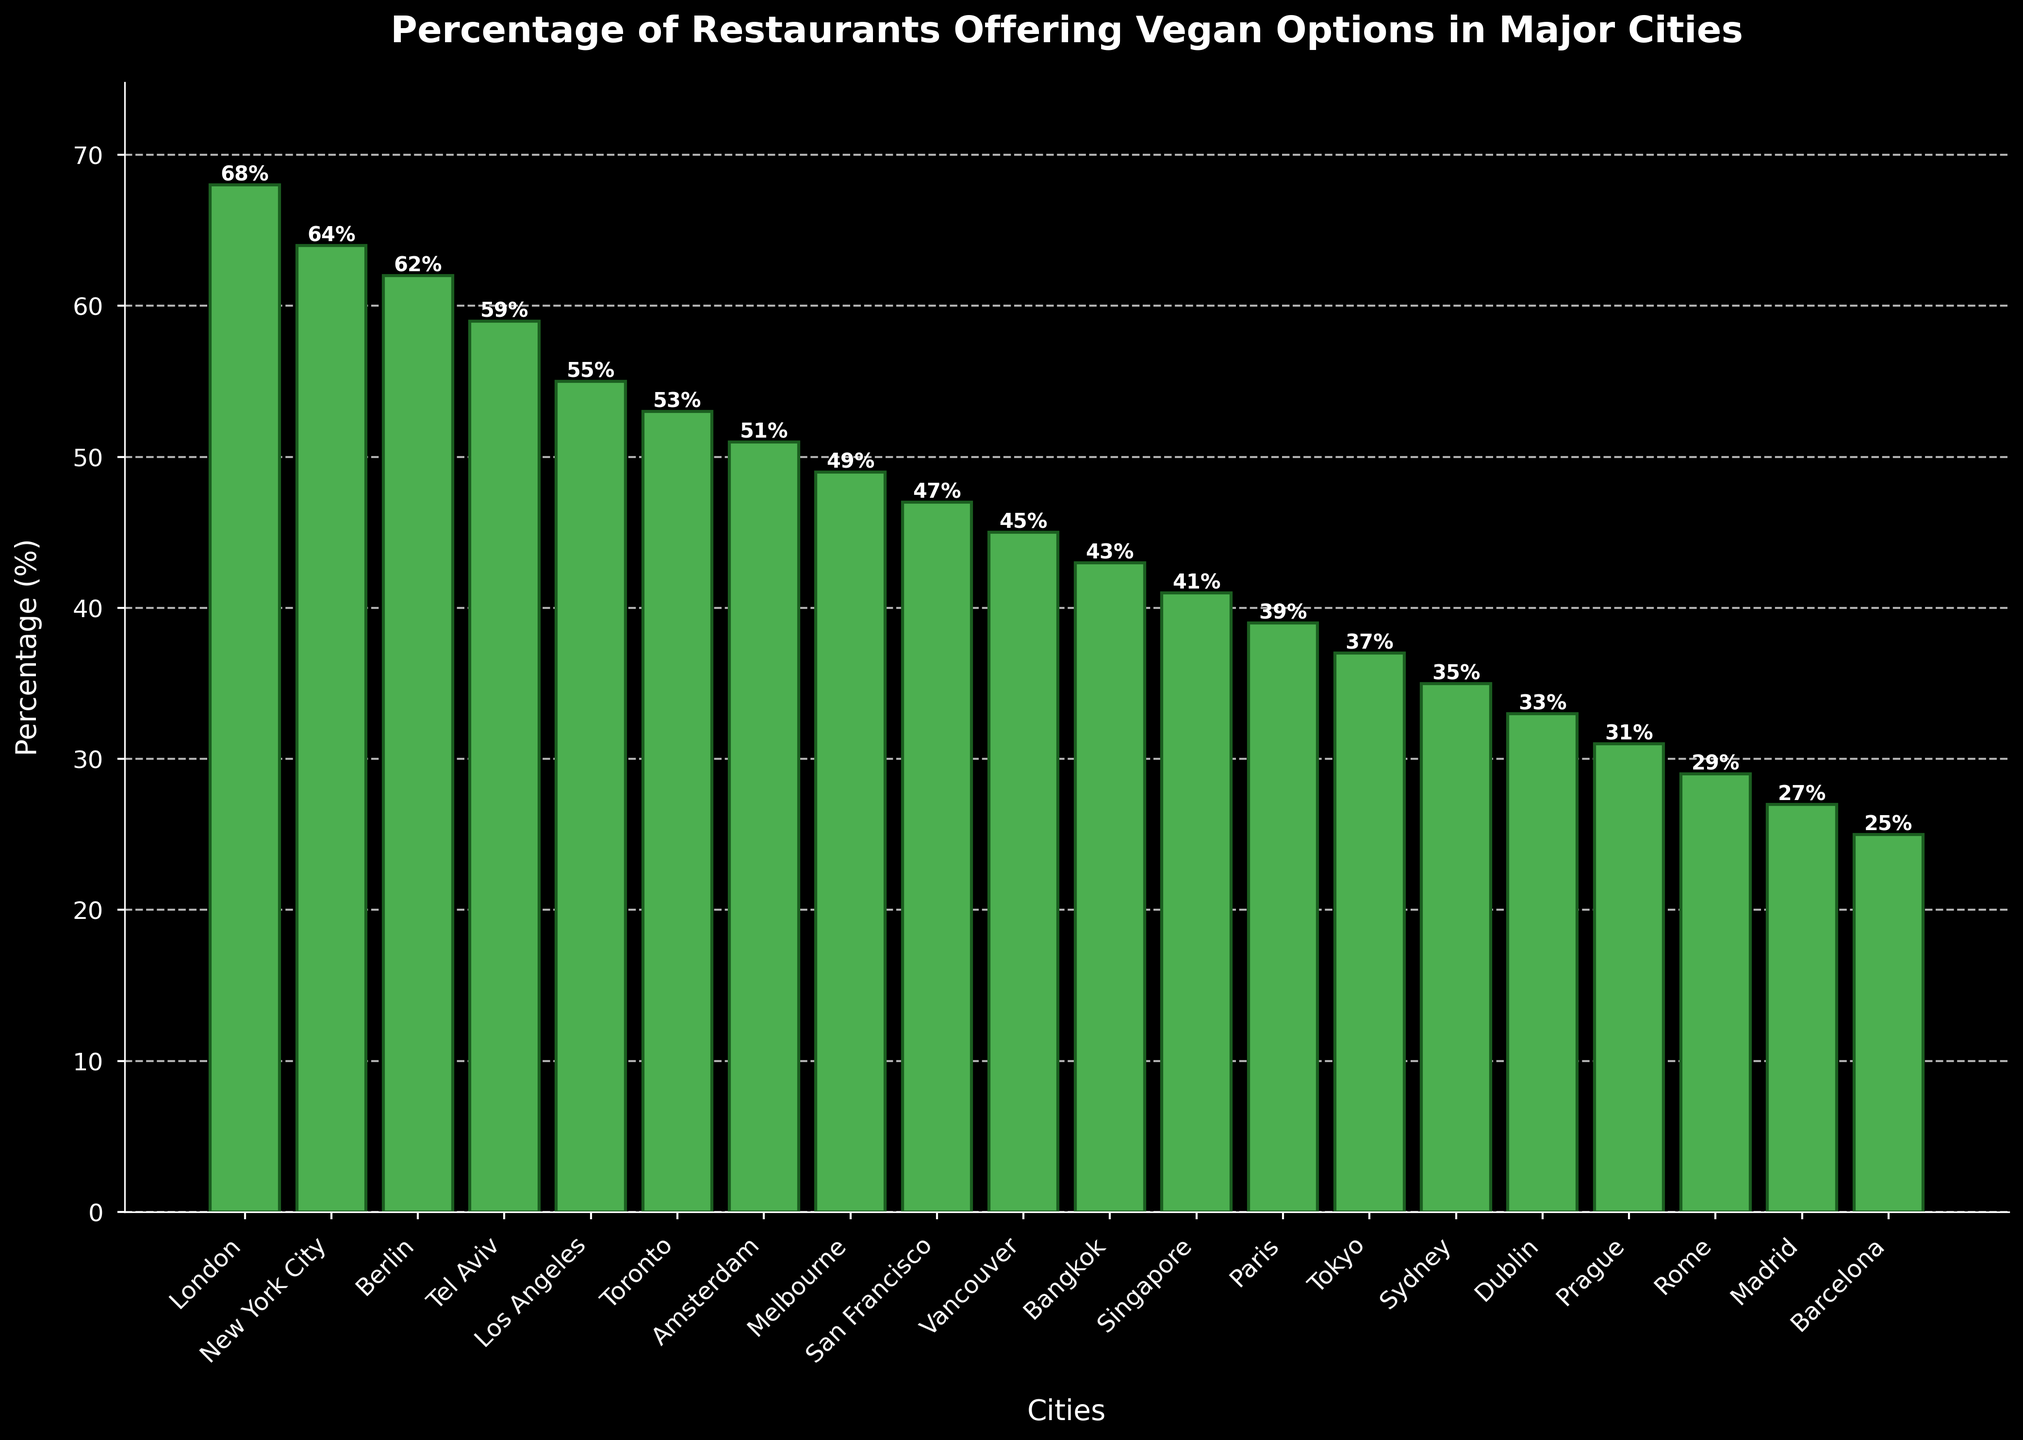Which city has the highest percentage of restaurants offering vegan options? The bar corresponding to "London" is the tallest in the chart, indicating it has the highest value. The percentage is explicitly stated as 68%, so London has the highest percentage.
Answer: London Which city has the lowest percentage of restaurants offering vegan options? The bar corresponding to "Barcelona" is the shortest, indicating it has the lowest value. The percentage is explicitly stated as 25%, so Barcelona has the lowest percentage.
Answer: Barcelona What is the average percentage of restaurants offering vegan options across all cities? To find the average, sum all the percentages given for each city and then divide by the number of cities. (68 + 64 + 62 + 59 + 55 + 53 + 51 + 49 + 47 + 45 + 43 + 41 + 39 + 37 + 35 + 33 + 31 + 29 + 27 + 25) / 20 = 49.5
Answer: 49.5 How many cities have more than 50% of restaurants offering vegan options? Count the number of cities where the bar height exceeds 50% in the chart. These cities are London, New York City, Berlin, Tel Aviv, Los Angeles, and Toronto. There are 6 cities in total.
Answer: 6 Which city has a higher percentage of restaurants offering vegan options: Melbourne or San Francisco? Compare the heights of the bars for Melbourne (49%) and San Francisco (47%). Melbourne has a higher percentage than San Francisco.
Answer: Melbourne What is the difference in percentage between the city with the highest and the city with the lowest vegan options? Subtract the percentage of Barcelona (25%) from the percentage of London (68%), which gives 68% - 25% = 43%.
Answer: 43 What is the median percentage of restaurants offering vegan options across all cities? Arrange the percentages in ascending order and find the middle value. The middle values are 41% and 43%, so the median is the average of these two values. (41 + 43) / 2 = 42%.
Answer: 42 Which city has slightly less than 40% of restaurants offering vegan options? Identify the bar height closest to but slightly less than 40%. The city with this percentage is Paris, which has 39% of restaurants offering vegan options.
Answer: Paris Are there more cities with vegan restaurant options above or below the average percentage? The average percentage is 49.5%. Count the number of cities above this value (6 cities: London, New York City, Berlin, Tel Aviv, Los Angeles, Toronto) and the number of cities below this value (14 cities). There are more cities below the average percentage.
Answer: Below 